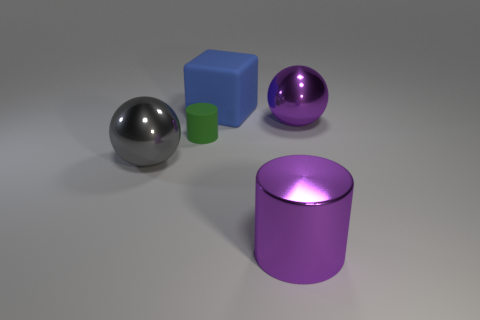Are there any other things that are the same size as the green rubber thing?
Provide a short and direct response. No. The metal sphere behind the shiny object that is left of the small green matte cylinder is what color?
Your response must be concise. Purple. What number of tiny objects are cyan metal balls or blue cubes?
Your response must be concise. 0. The metal thing that is both behind the large purple shiny cylinder and right of the rubber cube is what color?
Your answer should be compact. Purple. Do the big purple cylinder and the block have the same material?
Ensure brevity in your answer.  No. What is the shape of the large blue matte thing?
Your answer should be compact. Cube. How many large objects are on the right side of the big rubber block that is to the right of the thing that is to the left of the green matte object?
Offer a very short reply. 2. The other metal thing that is the same shape as the green object is what color?
Keep it short and to the point. Purple. What shape is the purple metal object that is behind the ball on the left side of the big purple shiny thing that is in front of the tiny rubber cylinder?
Your answer should be very brief. Sphere. There is a thing that is both behind the gray thing and in front of the big purple metallic ball; what is its size?
Make the answer very short. Small. 